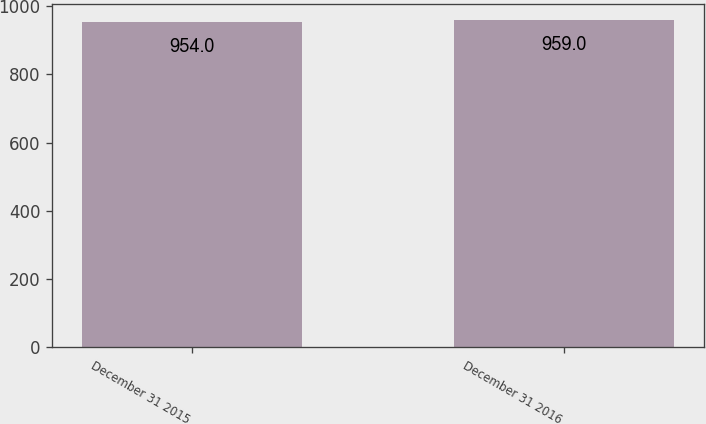Convert chart to OTSL. <chart><loc_0><loc_0><loc_500><loc_500><bar_chart><fcel>December 31 2015<fcel>December 31 2016<nl><fcel>954<fcel>959<nl></chart> 